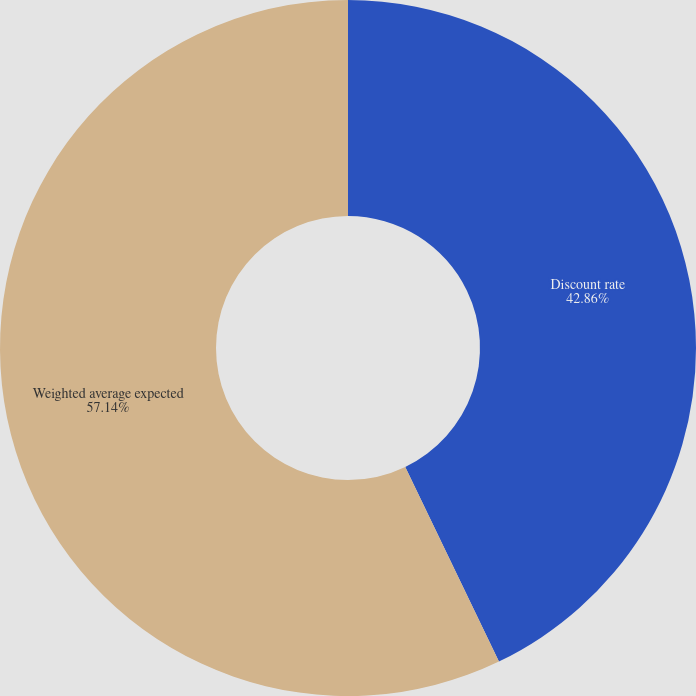Convert chart to OTSL. <chart><loc_0><loc_0><loc_500><loc_500><pie_chart><fcel>Discount rate<fcel>Weighted average expected<nl><fcel>42.86%<fcel>57.14%<nl></chart> 